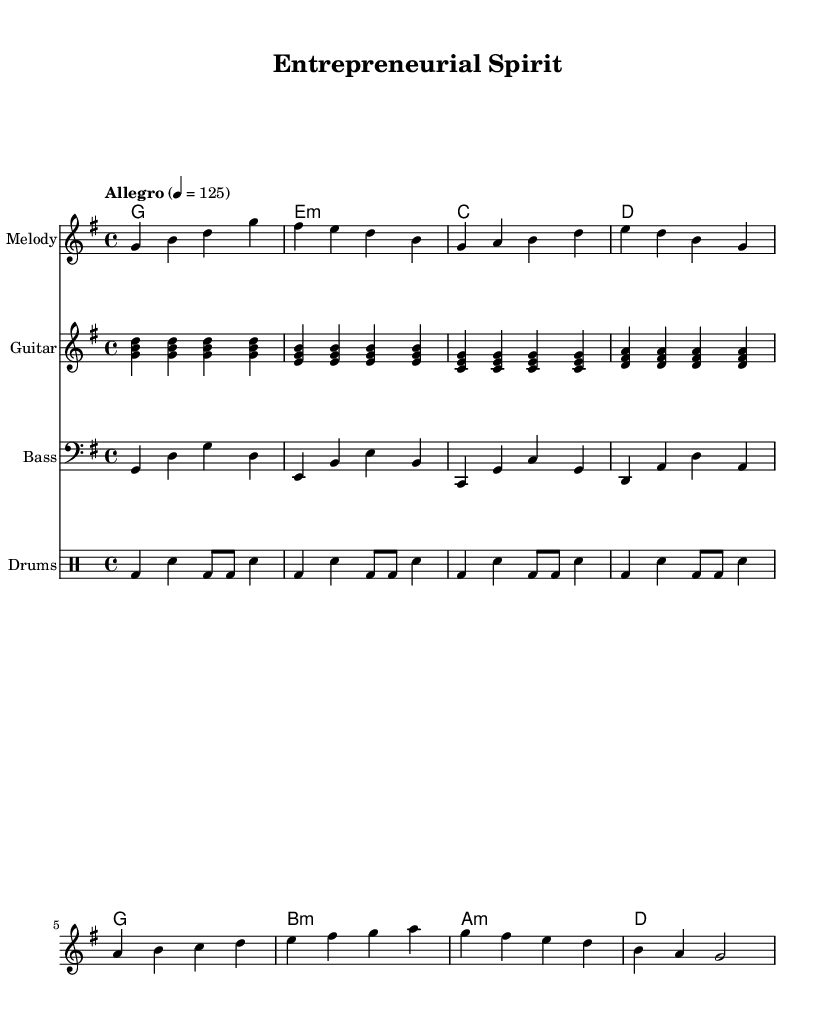What is the key signature of this music? The key signature is G major, which has one sharp (F#).
Answer: G major What is the time signature of the piece? The time signature is 4/4, indicating four beats per measure.
Answer: 4/4 What is the tempo marking of the music? The tempo marking indicates a tempo of Allegro, specifically 125 beats per minute.
Answer: 125 Which instrument doesn't use chord symbols? The melody staff does not include chord symbols as it focuses solely on the single melodic line.
Answer: Melody How many different chords are used in this piece? There are a total of seven different chords indicated in the chord section.
Answer: Seven What is the instrument designated for percussion in this score? The drum staff is designated for percussion in this score.
Answer: Drums In what way does the rhythm pattern of the drums contribute to the piece's uplifting character? The drum rhythm consists of strong beats and syncopation that adds energy and drive, characteristic of upbeat music.
Answer: Strong beats 